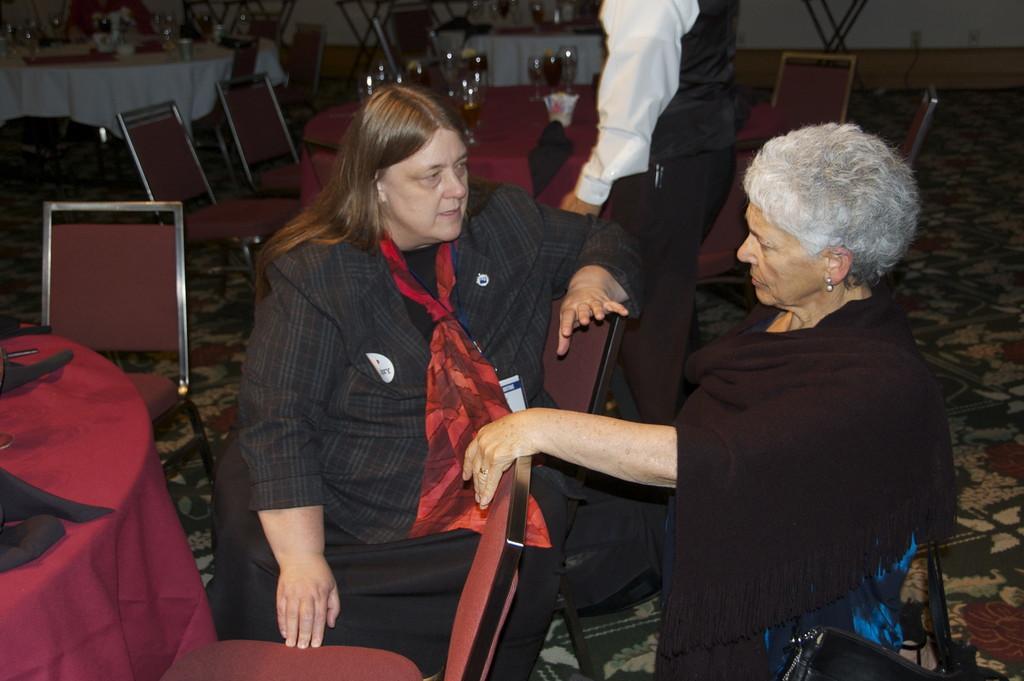Could you give a brief overview of what you see in this image? In this picture there are two women sitting in the chairs and talking to each other. In the background there is a person standing. There are some tables and chairs which were empty. We can observe a wall here. 